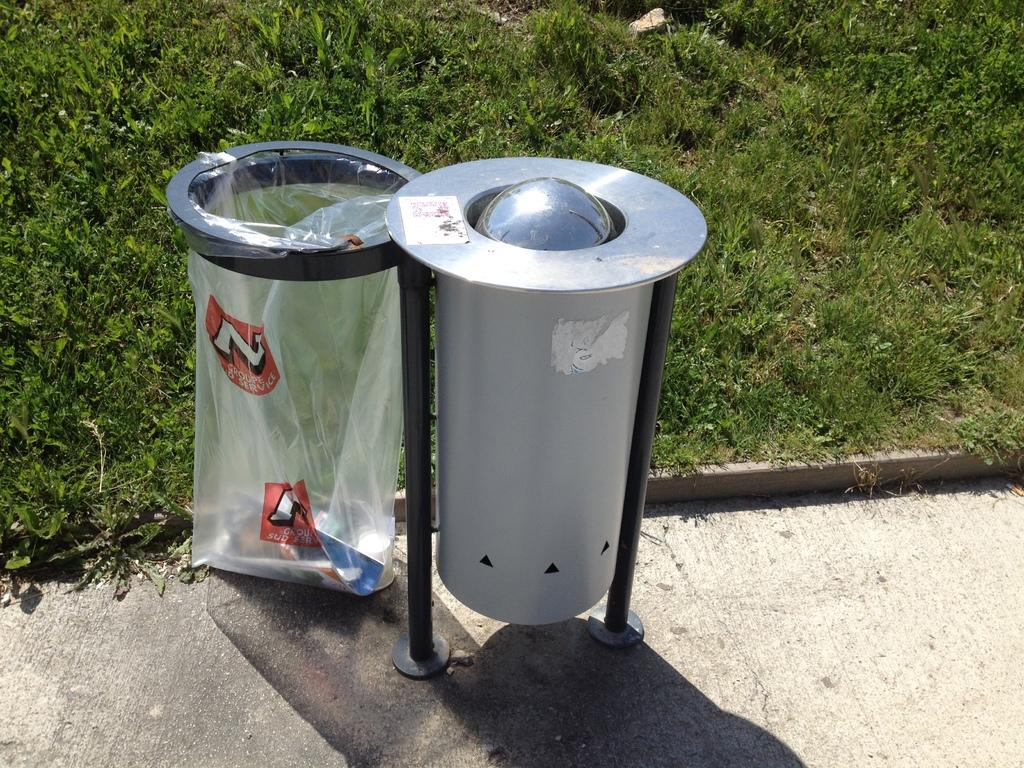<image>
Create a compact narrative representing the image presented. The garbage bag with the letter N on it 